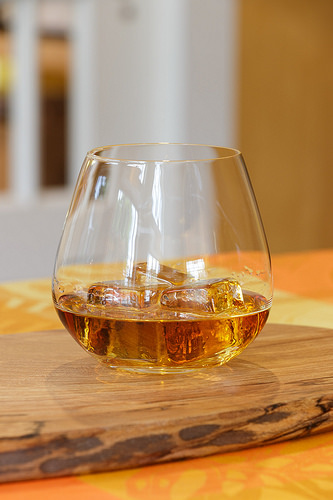<image>
Is the glass above the table? No. The glass is not positioned above the table. The vertical arrangement shows a different relationship. 